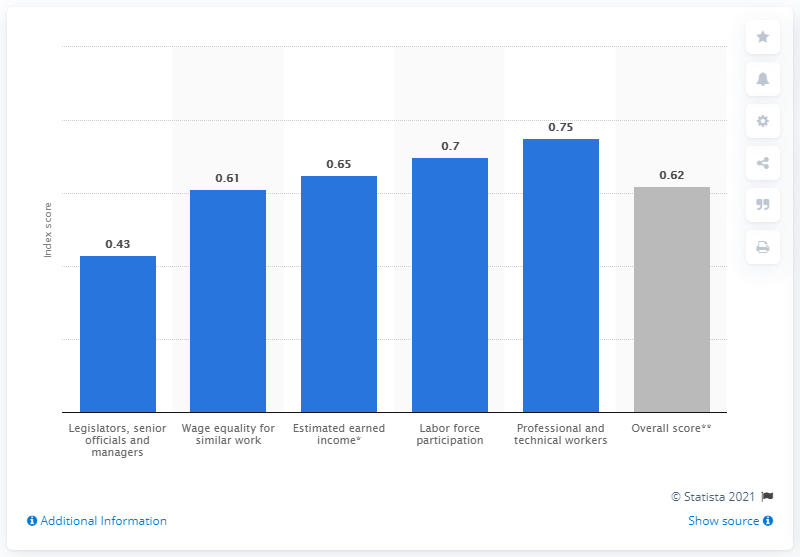Draw attention to some important aspects in this diagram. The gender gap index score in 2021 was 0.62, indicating a moderate gap between men and women in terms of political representation and economic participation. 